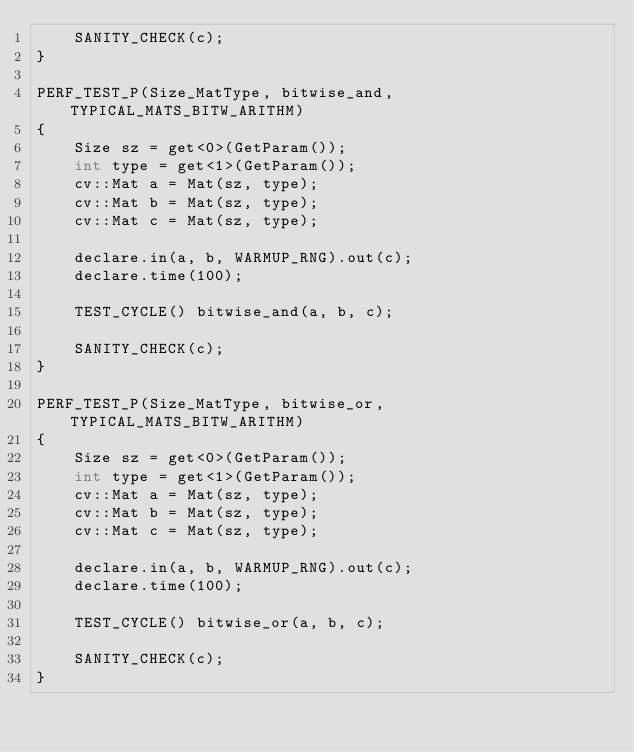Convert code to text. <code><loc_0><loc_0><loc_500><loc_500><_C++_>    SANITY_CHECK(c);
}

PERF_TEST_P(Size_MatType, bitwise_and, TYPICAL_MATS_BITW_ARITHM)
{
    Size sz = get<0>(GetParam());
    int type = get<1>(GetParam());
    cv::Mat a = Mat(sz, type);
    cv::Mat b = Mat(sz, type);
    cv::Mat c = Mat(sz, type);

    declare.in(a, b, WARMUP_RNG).out(c);
    declare.time(100);

    TEST_CYCLE() bitwise_and(a, b, c);

    SANITY_CHECK(c);
}

PERF_TEST_P(Size_MatType, bitwise_or, TYPICAL_MATS_BITW_ARITHM)
{
    Size sz = get<0>(GetParam());
    int type = get<1>(GetParam());
    cv::Mat a = Mat(sz, type);
    cv::Mat b = Mat(sz, type);
    cv::Mat c = Mat(sz, type);

    declare.in(a, b, WARMUP_RNG).out(c);
    declare.time(100);

    TEST_CYCLE() bitwise_or(a, b, c);

    SANITY_CHECK(c);
}
</code> 